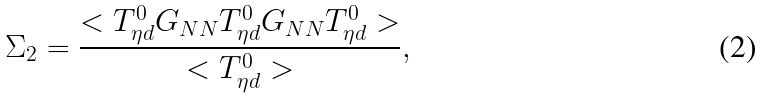Convert formula to latex. <formula><loc_0><loc_0><loc_500><loc_500>\Sigma _ { 2 } = \frac { < T ^ { 0 } _ { \eta d } G _ { N N } T ^ { 0 } _ { \eta d } G _ { N N } T ^ { 0 } _ { \eta d } > } { < T ^ { 0 } _ { \eta d } > } ,</formula> 